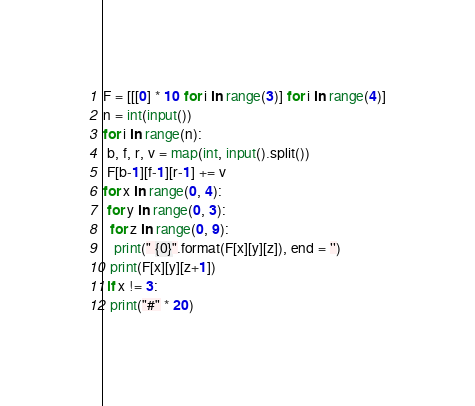Convert code to text. <code><loc_0><loc_0><loc_500><loc_500><_Python_>F = [[[0] * 10 for i in range(3)] for i in range(4)]
n = int(input())
for i in range(n):
 b, f, r, v = map(int, input().split())
 F[b-1][f-1][r-1] += v
for x in range(0, 4):
 for y in range(0, 3):
  for z in range(0, 9):
   print(" {0}".format(F[x][y][z]), end = '')
  print(F[x][y][z+1])
 if x != 3:
  print("#" * 20)</code> 